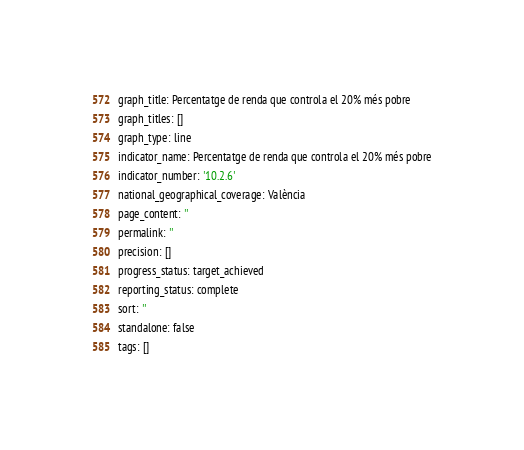<code> <loc_0><loc_0><loc_500><loc_500><_YAML_>graph_title: Percentatge de renda que controla el 20% més pobre
graph_titles: []
graph_type: line
indicator_name: Percentatge de renda que controla el 20% més pobre
indicator_number: '10.2.6'
national_geographical_coverage: València
page_content: ''
permalink: ''
precision: []
progress_status: target_achieved
reporting_status: complete
sort: ''
standalone: false
tags: []

</code> 